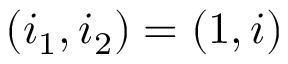<formula> <loc_0><loc_0><loc_500><loc_500>( i _ { 1 } , i _ { 2 } ) = ( 1 , i )</formula> 